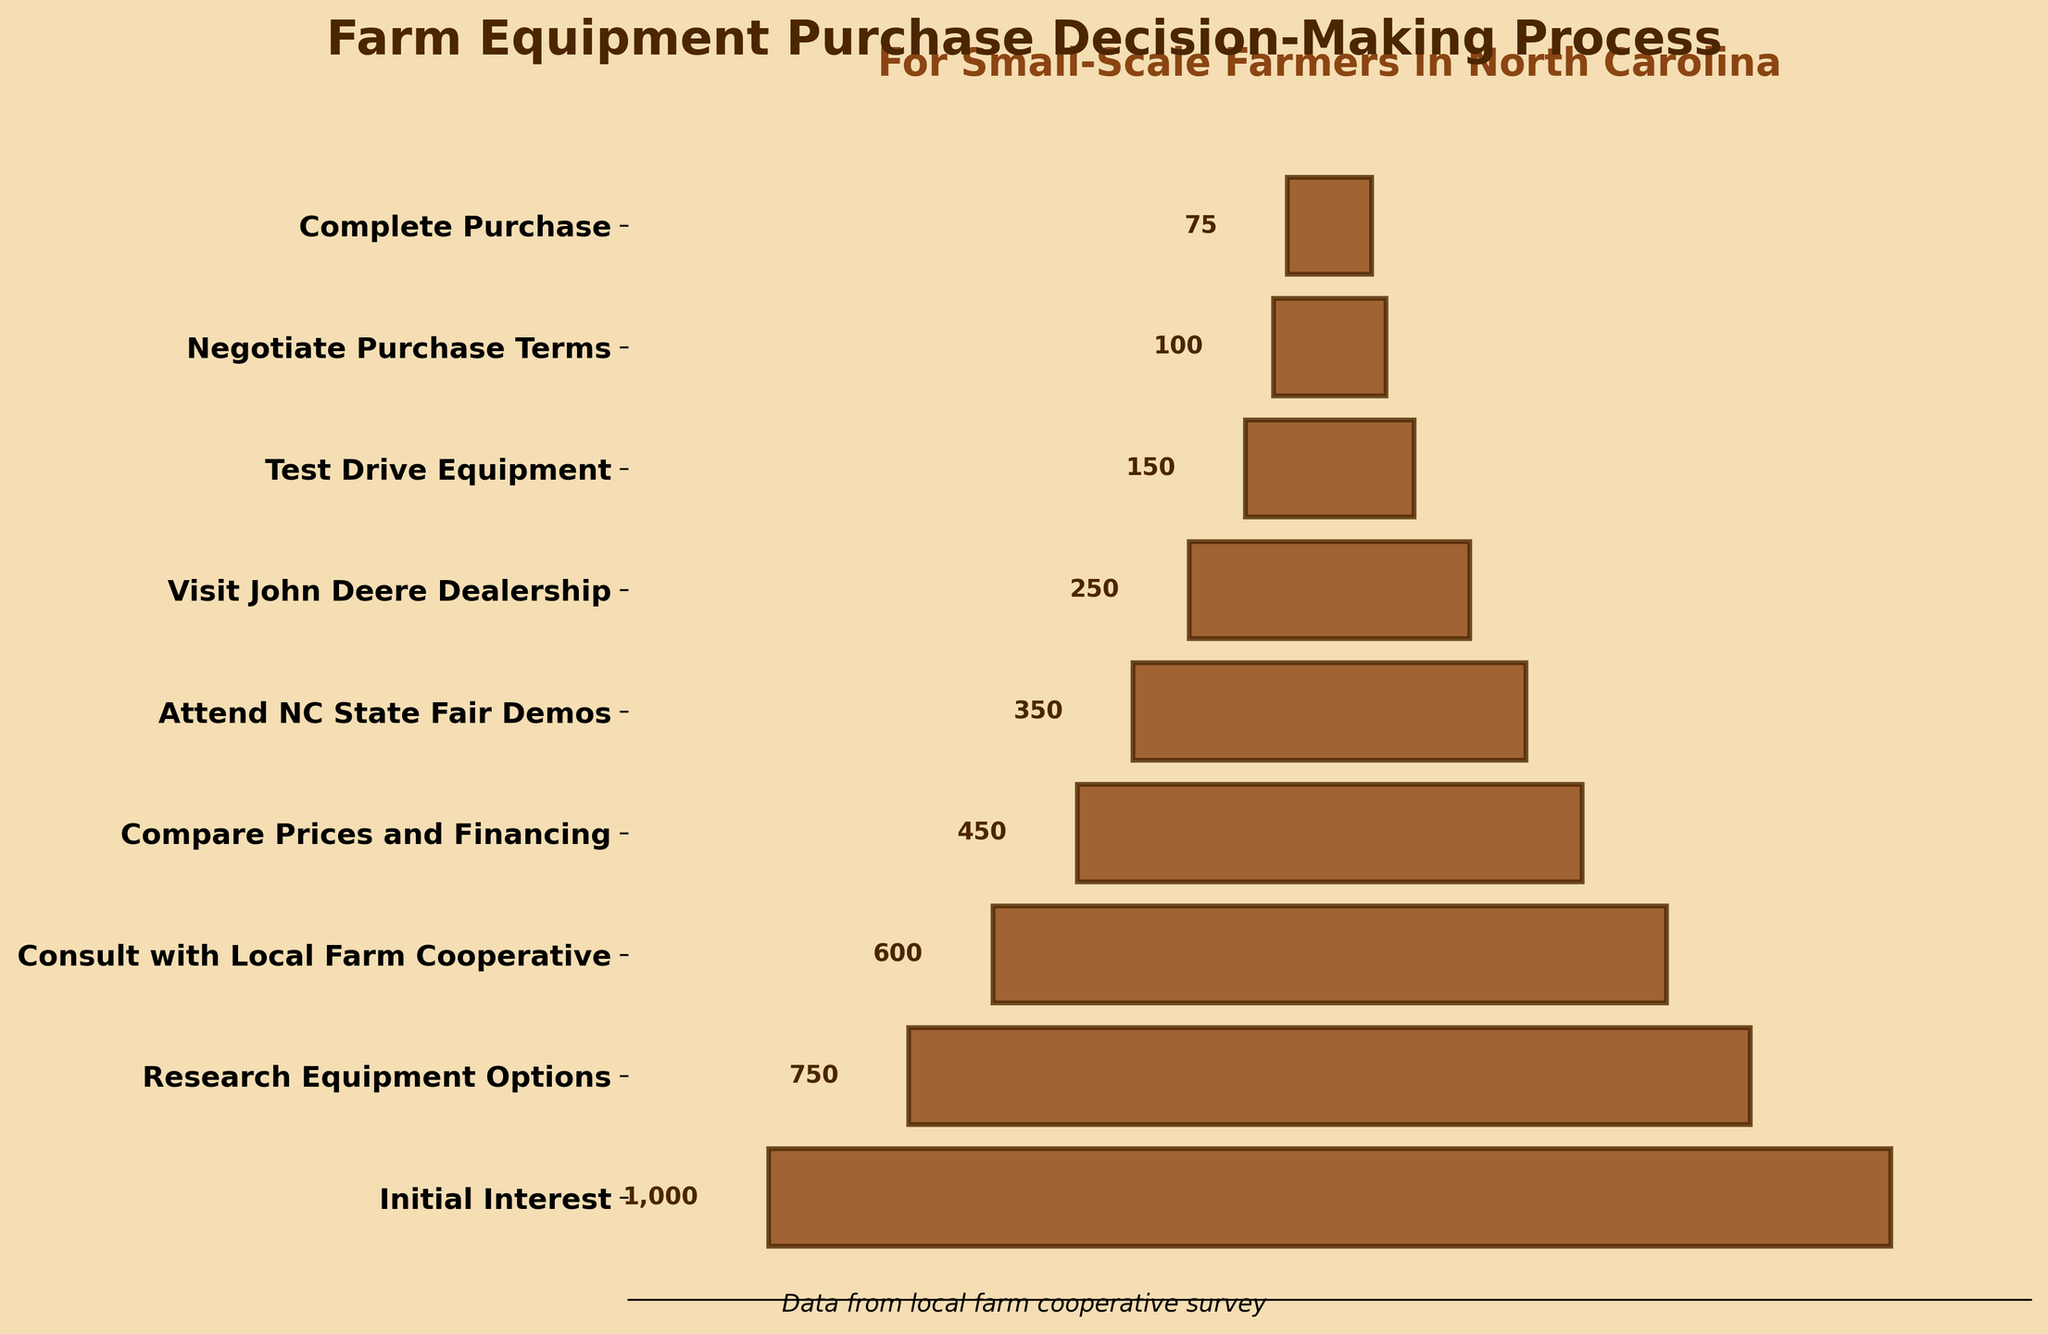How many farmers showed initial interest in purchasing farm equipment? The initial interest stage is shown at the top-most part of the funnel chart. The number of farmers in this stage is directly labeled.
Answer: 1000 At which stage did the number of farmers drop below 500? By observing the funnel stages from the top and labeling the numbers, the "Compare Prices and Financing" stage is the first one where the number drops below 500.
Answer: Compare Prices and Financing What is the difference in the number of farmers between the "Consult with Local Farm Cooperative" stage and the "Visit John Deere Dealership" stage? The number of farmers in the "Consult with Local Farm Cooperative" stage is 600 and in the "Visit John Deere Dealership" stage is 250. The difference is calculated as 600 - 250.
Answer: 350 Which stage immediately follows the stage where 600 farmers are engaged? By observing the sequence of the stages labeled on the y-axis, the stage immediately following "Consult with Local Farm Cooperative" (600 farmers) is "Compare Prices and Financing".
Answer: Compare Prices and Financing What percentage of the initial number of interested farmers completed the purchase? The initial number of farmers is 1000, and the number who completed the purchase is 75. The percentage is computed as (75 / 1000) * 100.
Answer: 7.5% How many more farmers attended the NC State Fair Demos compared to the John Deere Dealership? The number of farmers at the NC State Fair Demos is 350 and at the John Deere Dealership is 250. The difference is calculated as 350 - 250.
Answer: 100 Which stage has the smallest number of farmers and how many farmers are in that stage? Observing the funnel chart from top to bottom, the stage with the smallest number of farmers is the "Complete Purchase" stage, where the number of farmers is 75.
Answer: Complete Purchase, 75 What is the cumulative number of farmers involved in the first three stages? The number of farmers in the first three stages are 1000 (Initial Interest), 750 (Research Equipment Options), and 600 (Consult with Local Farm Cooperative). The cumulative number is calculated as 1000 + 750 + 600.
Answer: 2350 Between which two consecutive stages is the largest drop in the number of farmers observed? By examining the differences between consecutive stages: 
- Initial Interest to Research Equipment Options: 1000 - 750 = 250
- Research Equipment Options to Consult with Local Farm Cooperative: 750 - 600 = 150
- Consult with Local Farm Cooperative to Compare Prices and Financing: 600 - 450 = 150
- Compare Prices and Financing to Attend NC State Fair Demos: 450 - 350 = 100
- Attend NC State Fair Demos to Visit John Deere Dealership: 350 - 250 = 100
- Visit John Deere Dealership to Test Drive Equipment: 250 - 150 = 100
- Test Drive Equipment to Negotiate Purchase Terms: 150 - 100 = 50
- Negotiate Purchase Terms to Complete Purchase: 100 - 75 = 25
The largest drop of 250 farmers occurs between the Initial Interest and Research Equipment Options stages.
Answer: Initial Interest and Research Equipment Options 